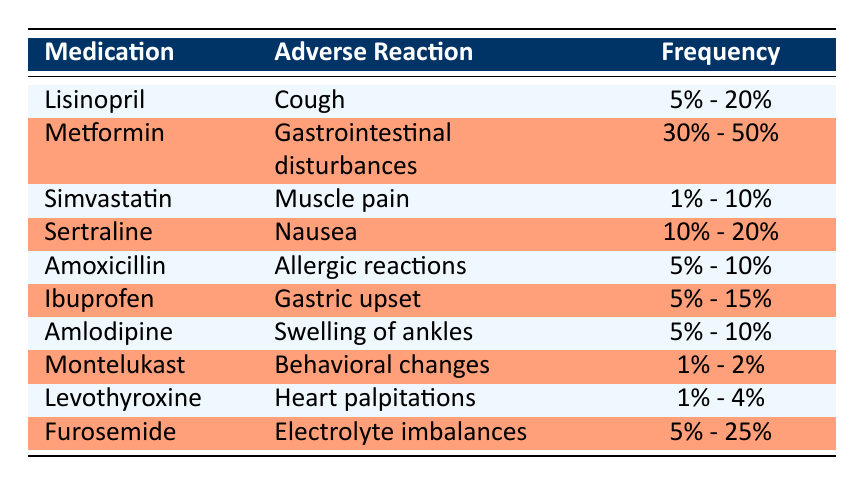What's the frequency of adverse reactions for Metformin? The table states the frequency of gastrointestinal disturbances reported by patients on Metformin as 30% - 50%.
Answer: 30% - 50% Which medication has a reported adverse reaction of muscle pain? By examining the table, we can see that Simvastatin is listed under "Adverse Reaction" for muscle pain.
Answer: Simvastatin Is the frequency of nausea for Sertraline higher than that of cough for Lisinopril? The frequency for Sertraline (10% - 20%) is higher than that for Lisinopril (5% - 20%) since the maximum for Lisinopril is only 20%.
Answer: Yes What is the average frequency of adverse drug reactions for medications with a frequency range of 5% - 10%? The medications with this frequency are Amoxicillin, Amlodipine, and Simvastatin. We take the average of the ranges: (5 + 10 + 5 + 10 + 1 + 10) / 6 which approximates to about 7.5%.
Answer: Approximately 7.5% Are there any medications listed that have a frequency of adverse reactions less than 5%? The table does not list any medications with frequencies below 1%, meaning there are no medications reported below 5% frequency.
Answer: No Which medication has the highest frequency of adverse drug reactions? The table indicates Metformin has the highest frequency with gastrointestinal disturbances at 30% - 50%, which is the largest range noted.
Answer: Metformin If a patient experiences heart palpitations, which medication might they be taking? Looking at the table, Levothyroxine is associated with heart palpitations as an adverse reaction and is the medication listed for it.
Answer: Levothyroxine How many medications listed have a frequency of adverse reactions between 10% and 20%? From the table, Lisinopril and Sertraline both have adverse reactions with frequencies in the range of 10% - 20%. Hence, there are two medications in that frequency range.
Answer: 2 